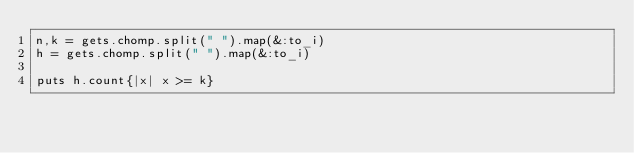<code> <loc_0><loc_0><loc_500><loc_500><_Ruby_>n,k = gets.chomp.split(" ").map(&:to_i)
h = gets.chomp.split(" ").map(&:to_i)

puts h.count{|x| x >= k}</code> 